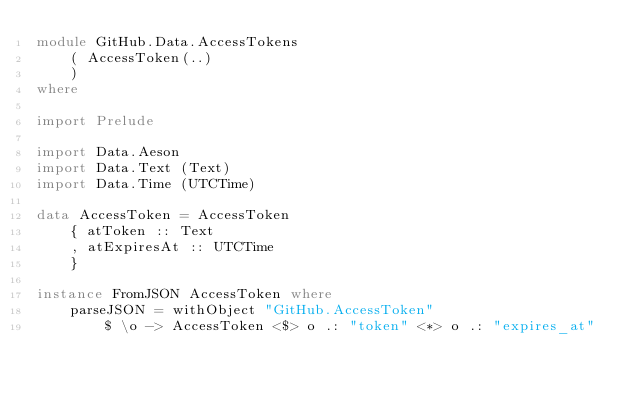Convert code to text. <code><loc_0><loc_0><loc_500><loc_500><_Haskell_>module GitHub.Data.AccessTokens
    ( AccessToken(..)
    )
where

import Prelude

import Data.Aeson
import Data.Text (Text)
import Data.Time (UTCTime)

data AccessToken = AccessToken
    { atToken :: Text
    , atExpiresAt :: UTCTime
    }

instance FromJSON AccessToken where
    parseJSON = withObject "GitHub.AccessToken"
        $ \o -> AccessToken <$> o .: "token" <*> o .: "expires_at"
</code> 